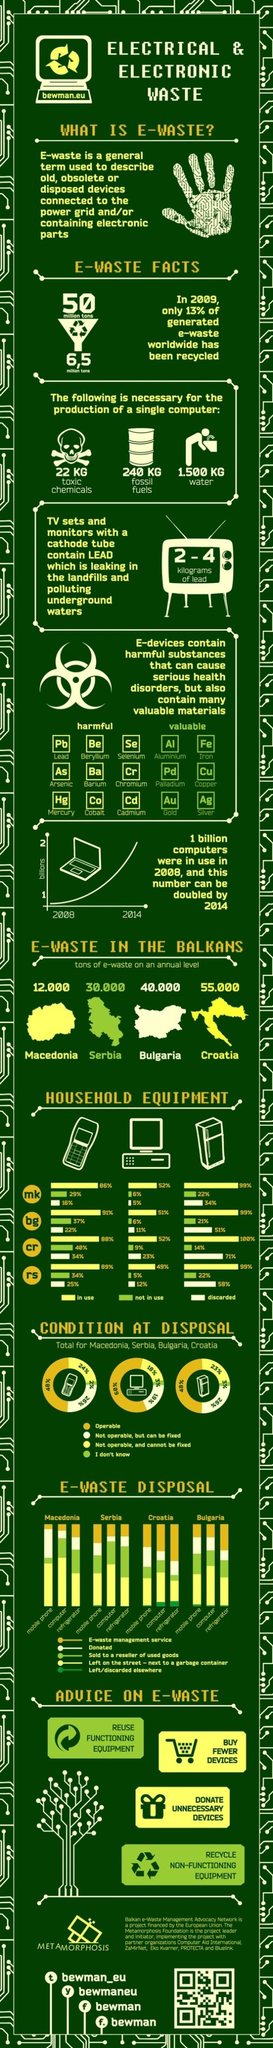Highlight a few significant elements in this photo. Approximately 48% of mobile devices are operable. The production of a single computer requires a significant amount of toxic chemicals, with an estimated 22 kilograms needed. Approximately 55,000 metric tons of electronic waste is generated in Croatia each year. The amount of E-waste in Bulgaria is approximately 40,000.. The production of a single computer requires 1.500 kg of water, which is a significant amount considering the potential environmental impact of the technology industry. 